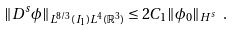<formula> <loc_0><loc_0><loc_500><loc_500>\| D ^ { s } \phi \| _ { L ^ { 8 / 3 } ( I _ { 1 } ) L ^ { 4 } ( \mathbb { R } ^ { 3 } ) } \leq 2 C _ { 1 } \| \phi _ { 0 } \| _ { H ^ { s } } \ .</formula> 